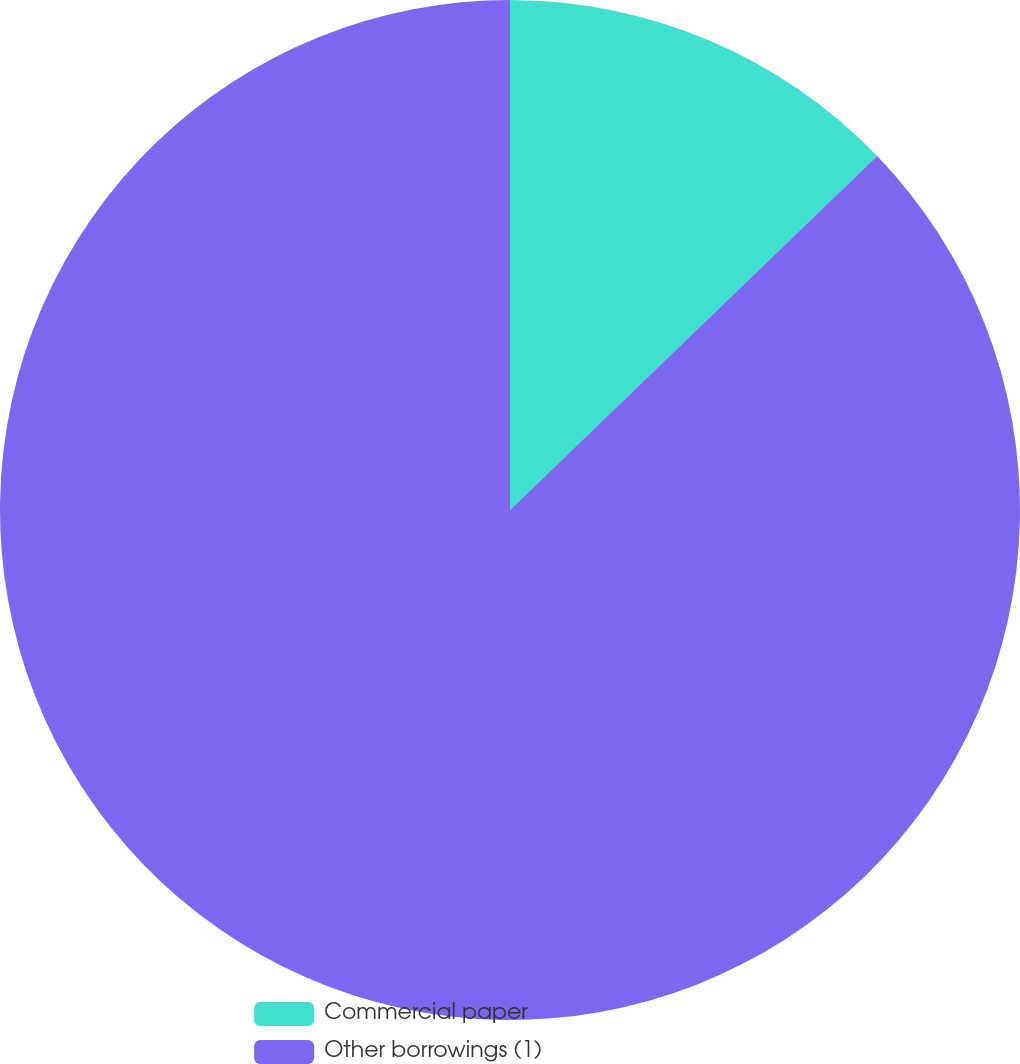Convert chart. <chart><loc_0><loc_0><loc_500><loc_500><pie_chart><fcel>Commercial paper<fcel>Other borrowings (1)<nl><fcel>12.79%<fcel>87.21%<nl></chart> 